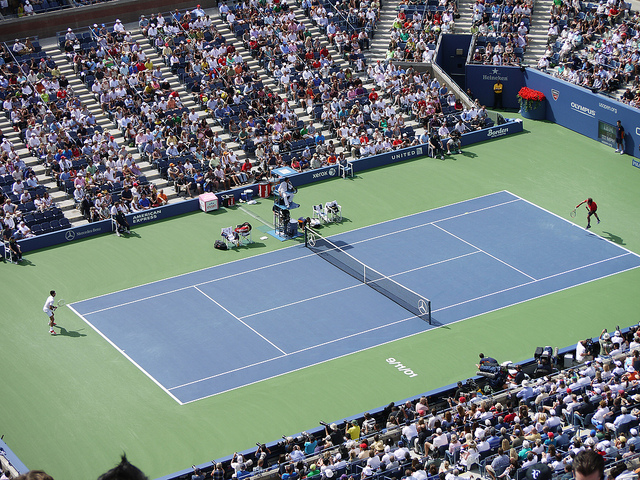<image>How big is the stadium? It is uncertain how big the stadium is. It could be big, very big, or small. How big is the stadium? I don't know how big the stadium is. It can be both big and very big. 